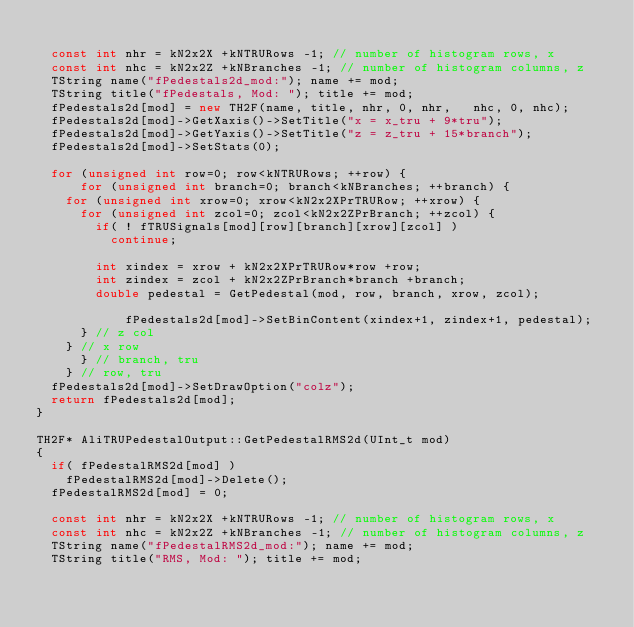<code> <loc_0><loc_0><loc_500><loc_500><_C++_>
  const int nhr = kN2x2X +kNTRURows -1; // number of histogram rows, x
  const int nhc = kN2x2Z +kNBranches -1; // number of histogram columns, z
  TString name("fPedestals2d_mod:"); name += mod;
  TString title("fPedestals, Mod: "); title += mod;
  fPedestals2d[mod] = new TH2F(name, title, nhr, 0, nhr,   nhc, 0, nhc);
  fPedestals2d[mod]->GetXaxis()->SetTitle("x = x_tru + 9*tru");
  fPedestals2d[mod]->GetYaxis()->SetTitle("z = z_tru + 15*branch");
  fPedestals2d[mod]->SetStats(0);

  for (unsigned int row=0; row<kNTRURows; ++row) {
      for (unsigned int branch=0; branch<kNBranches; ++branch) {
	for (unsigned int xrow=0; xrow<kN2x2XPrTRURow; ++xrow) {
	  for (unsigned int zcol=0; zcol<kN2x2ZPrBranch; ++zcol) {
	    if( ! fTRUSignals[mod][row][branch][xrow][zcol] )
	      continue;

	    int xindex = xrow + kN2x2XPrTRURow*row +row;
	    int zindex = zcol + kN2x2ZPrBranch*branch +branch;
	    double pedestal = GetPedestal(mod, row, branch, xrow, zcol);

    	    fPedestals2d[mod]->SetBinContent(xindex+1, zindex+1, pedestal);
	  } // z col
	} // x row
      } // branch, tru
    } // row, tru
  fPedestals2d[mod]->SetDrawOption("colz");
  return fPedestals2d[mod];
}

TH2F* AliTRUPedestalOutput::GetPedestalRMS2d(UInt_t mod)
{
  if( fPedestalRMS2d[mod] )
    fPedestalRMS2d[mod]->Delete();
  fPedestalRMS2d[mod] = 0;

  const int nhr = kN2x2X +kNTRURows -1; // number of histogram rows, x
  const int nhc = kN2x2Z +kNBranches -1; // number of histogram columns, z
  TString name("fPedestalRMS2d_mod:"); name += mod;
  TString title("RMS, Mod: "); title += mod;</code> 